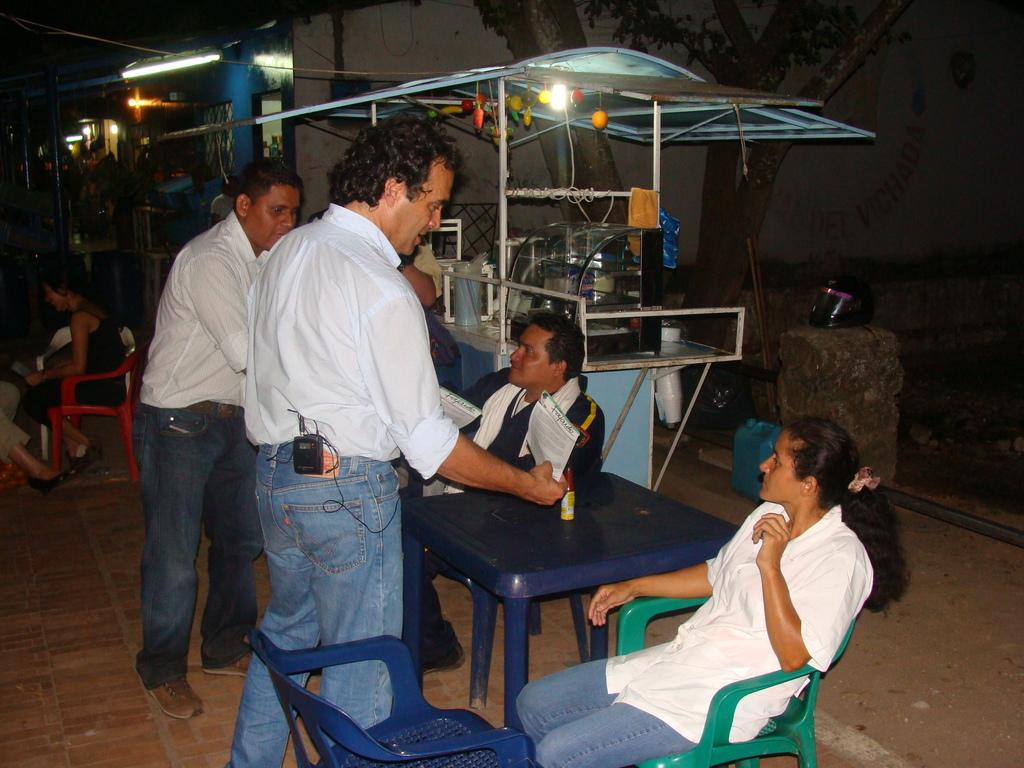How many people are in the image? There are people in the image, but the exact number is not specified. What are the people doing in the image? Some people are standing, while others are sitting on chairs. What can be seen in the background of the image? There is a stall, a tree, and a building in the background of the image. What is the distance between the people and the airplane in the image? There is no airplane present in the image, so it is not possible to determine the distance between the people and an airplane. 